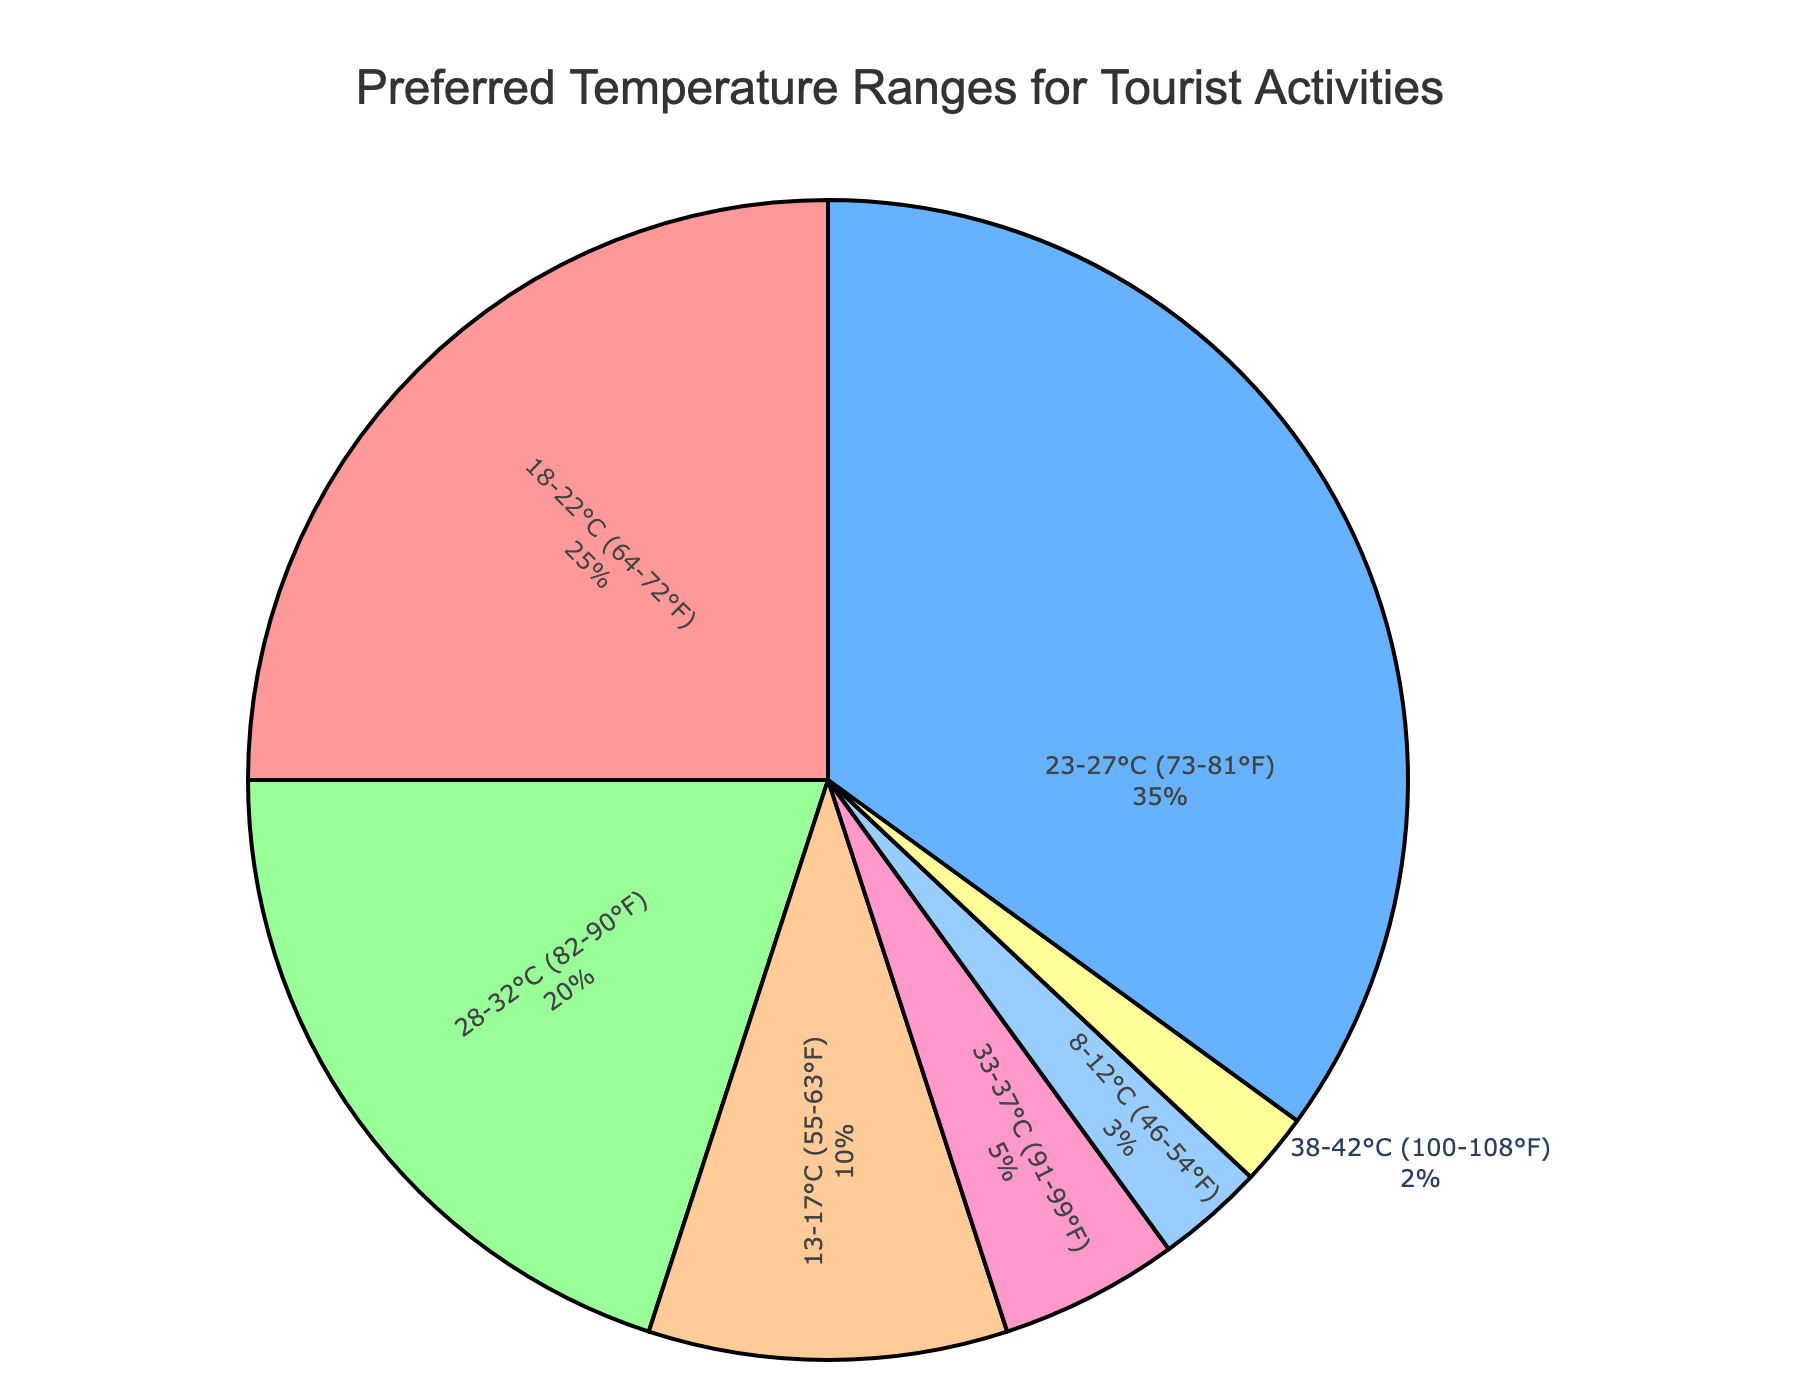What's the most preferred temperature range for tourist activities? To find the most preferred temperature range, look for the largest segment in the pie chart, which corresponds to the highest percentage. The 23-27°C range has the largest segment at 35%.
Answer: 23-27°C (73-81°F) Which temperature range is the least preferred? The least preferred temperature range will have the smallest segment in the pie chart, indicated by the lowest percentage. The 38-42°C range has the smallest segment at 2%.
Answer: 38-42°C (100-108°F) What is the combined preference percentage for temperature ranges below 18°C (64°F)? Add the percentages of all temperature ranges below 18°C: 13-17°C (10%) + 8-12°C (3%) = 10% + 3% = 13%.
Answer: 13% How much more popular is the 23-27°C range compared to the 28-32°C range? Subtract the percentage of the 28-32°C range from the 23-27°C range: 35% - 20% = 15%.
Answer: 15% What is the difference in preference between the 18-22°C and the 33-37°C temperature ranges? Subtract the 33-37°C range percentage from the 18-22°C range percentage: 25% - 5% = 20%.
Answer: 20% Which temperature range is represented by the green color? The green color corresponds to the second-largest segment in the pie chart. Looking at the given color palette, green represents the 28-32°C range (20%).
Answer: 28-32°C (82-90°F) If you combined the preferences for 23-27°C and 28-32°C, what would be the total percentage? Add the percentages of the 23-27°C range and the 28-32°C range: 35% + 20% = 55%.
Answer: 55% How does the preference for the 33-37°C range compare to the 8-12°C range? The pie chart segments show that the 33-37°C range (5%) has a larger percentage than the 8-12°C range (3%).
Answer: 33-37°C range is more preferred by 2% Which temperature ranges together make up more than half of the total preferences? Determine the ranges that sum to over 50%. The 23-27°C range (35%) and the 18-22°C range (25%) add up to 35% + 25% = 60%. Together, they make up more than half of the total preferences.
Answer: 23-27°C and 18-22°C 